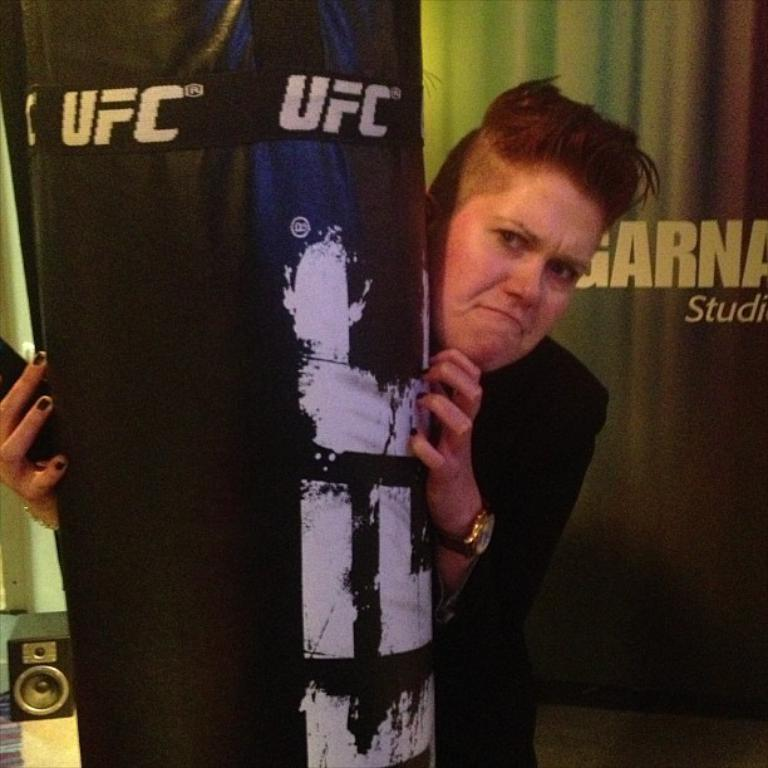<image>
Relay a brief, clear account of the picture shown. A woman stands behind a UFC branded punch bag. 